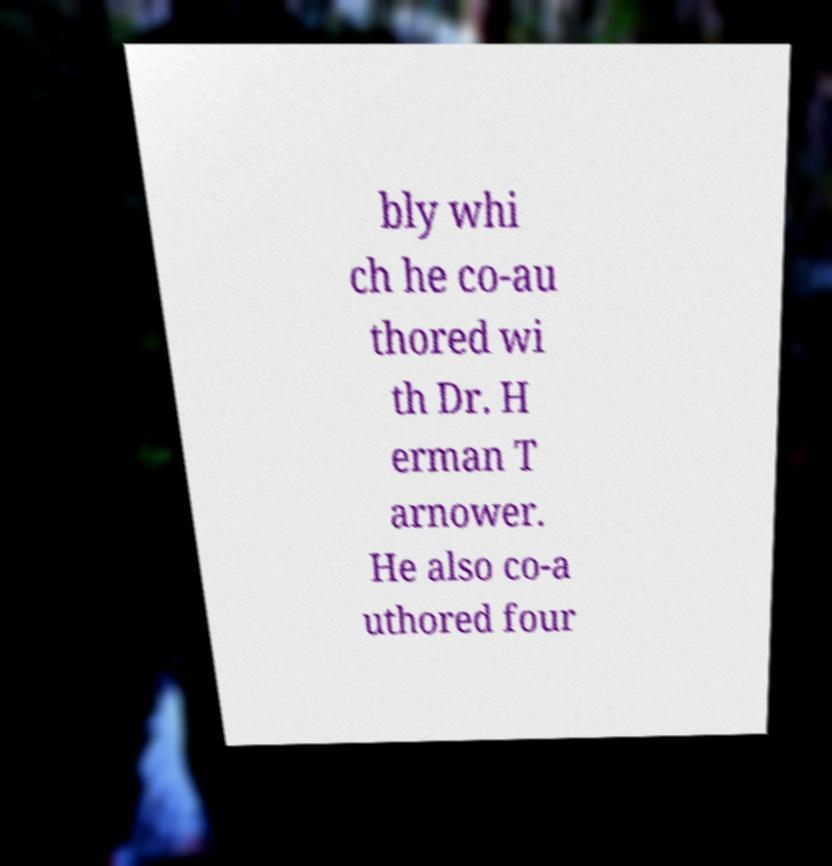Could you assist in decoding the text presented in this image and type it out clearly? bly whi ch he co-au thored wi th Dr. H erman T arnower. He also co-a uthored four 